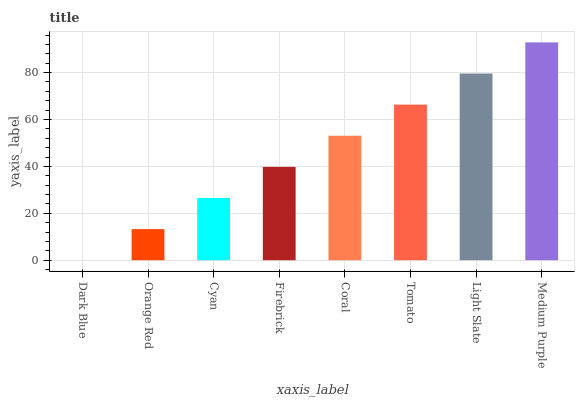Is Orange Red the minimum?
Answer yes or no. No. Is Orange Red the maximum?
Answer yes or no. No. Is Orange Red greater than Dark Blue?
Answer yes or no. Yes. Is Dark Blue less than Orange Red?
Answer yes or no. Yes. Is Dark Blue greater than Orange Red?
Answer yes or no. No. Is Orange Red less than Dark Blue?
Answer yes or no. No. Is Coral the high median?
Answer yes or no. Yes. Is Firebrick the low median?
Answer yes or no. Yes. Is Light Slate the high median?
Answer yes or no. No. Is Cyan the low median?
Answer yes or no. No. 